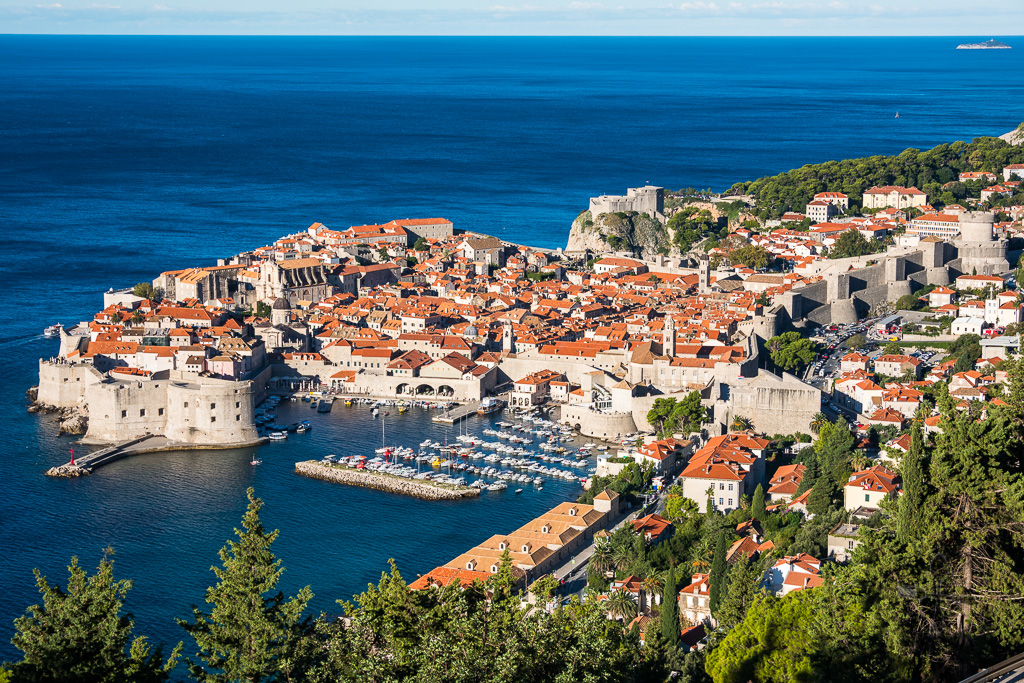If you were a bird, where would you perch to get the best view of Dubrovnik? If I were a bird seeking the best view of Dubrovnik, I would perch atop the Minceta Tower. Standing as the highest point on the city walls, this vantage point offers an unparalleled panoramic view of Dubrovnik. From here, you can look down upon the terracotta roofs, the intricate layout of the narrow streets, and the bustling harbor filled with boats. The sweep of the Adriatic, with its captivating hues of blue, would spread out before me, capturing the essence of Dubrovnik's blending of natural beauty and historical architecture. 